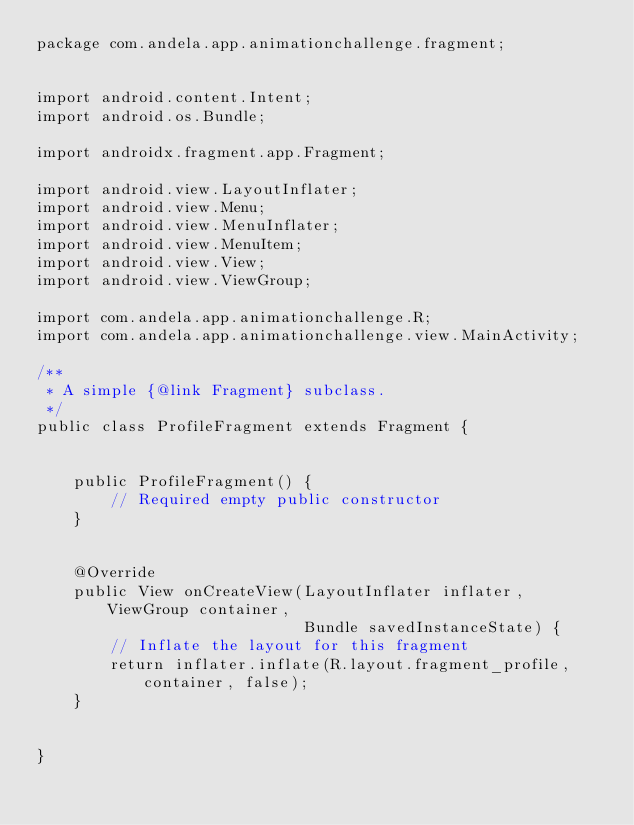<code> <loc_0><loc_0><loc_500><loc_500><_Java_>package com.andela.app.animationchallenge.fragment;


import android.content.Intent;
import android.os.Bundle;

import androidx.fragment.app.Fragment;

import android.view.LayoutInflater;
import android.view.Menu;
import android.view.MenuInflater;
import android.view.MenuItem;
import android.view.View;
import android.view.ViewGroup;

import com.andela.app.animationchallenge.R;
import com.andela.app.animationchallenge.view.MainActivity;

/**
 * A simple {@link Fragment} subclass.
 */
public class ProfileFragment extends Fragment {


    public ProfileFragment() {
        // Required empty public constructor
    }


    @Override
    public View onCreateView(LayoutInflater inflater, ViewGroup container,
                             Bundle savedInstanceState) {
        // Inflate the layout for this fragment
        return inflater.inflate(R.layout.fragment_profile, container, false);
    }


}
</code> 